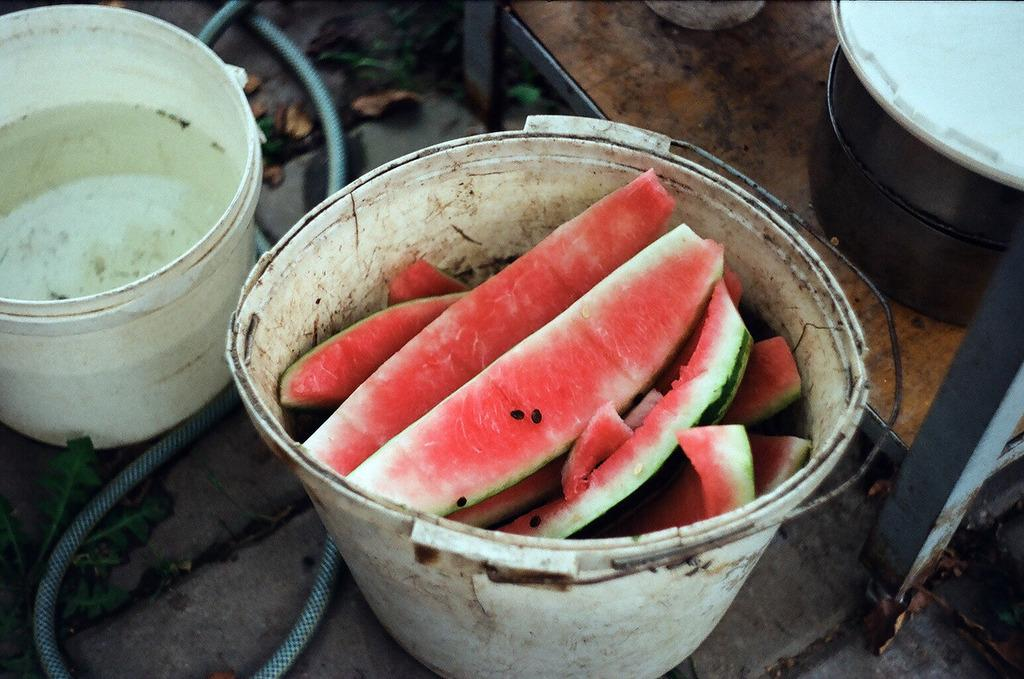How many buckets are in the image? There are two white color buckets in the image. What is the content of the first bucket? The first bucket contains water. What is the content of the second bucket? The second bucket contains watermelons. What can be seen connected to the water pipe in the image? The water pipe is not connected to any visible object in the image. What type of square game is being played on the ground in the image? There is no square game present in the image; it only features two buckets and a water pipe. How many times has the wash cycle been completed in the image? There is no washing machine or any indication of a wash cycle in the image. 